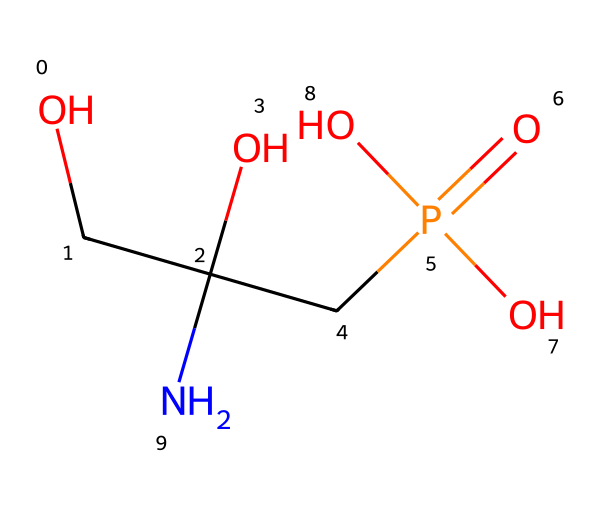What is the molecular formula of glyphosate? To determine the molecular formula, we can count the number of each type of atom in the SMILES representation: C (carbon), H (hydrogen), N (nitrogen), O (oxygen), and P (phosphorus). The SMILES shows 3 carbons, 8 hydrogens, 1 nitrogen, 4 oxygens, and 1 phosphorus, leading to the formula C3H8NO5P.
Answer: C3H8NO5P How many oxygen atoms are present in glyphosate? By examining the SMILES string, we identify four 'O' symbols, indicating the presence of four oxygen atoms.
Answer: 4 What type of chemical is glyphosate? Glyphosate is commonly recognized as an organophosphorus compound due to the presence of the phosphorus atom connected to oxygen groups.
Answer: organophosphorus What functional groups are present in glyphosate? The structure shows several functional groups: an amine (due to nitrogen), alcohols (due to the hydroxyl groups), and a phosphate group, indicating several reactivity sites.
Answer: amine, alcohols, phosphate How many hydrogen atoms are bonded to the nitrogen in glyphosate? The nitrogen in the structure has two hydrogen atoms directly bonded to it as represented in the SMILES string.
Answer: 2 What aspect of glyphosate structure contributes to its herbicidal activity? The presence of the phosphate group in glyphosate is crucial as it interacts with specific enzymes in plants, inhibiting their growth. This specific functional group plays a vital role in glyphosate's herbicidal function due to its ability to mimic amino acids.
Answer: phosphate group Is glyphosate considered hazardous? Yes, glyphosate is classified as a hazardous chemical and can pose risks to human health and the environment based on various studies linking it to health problems and ecological impacts.
Answer: yes 